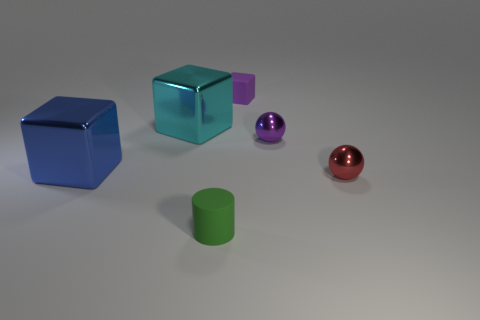What number of objects are cylinders or big purple rubber cylinders?
Give a very brief answer. 1. There is a shiny thing that is both in front of the purple shiny thing and to the right of the cyan metal cube; what is its shape?
Keep it short and to the point. Sphere. What number of tiny purple rubber cubes are there?
Ensure brevity in your answer.  1. There is a thing that is the same material as the cylinder; what color is it?
Offer a very short reply. Purple. Is the number of red metal balls greater than the number of big green cubes?
Your response must be concise. Yes. What is the size of the thing that is in front of the blue shiny cube and behind the cylinder?
Your response must be concise. Small. There is a tiny object that is the same color as the small block; what is it made of?
Provide a succinct answer. Metal. Is the number of large metallic objects on the right side of the blue metal cube the same as the number of small matte cubes?
Offer a very short reply. Yes. Is the cyan thing the same size as the matte block?
Make the answer very short. No. What is the color of the tiny thing that is in front of the small purple metallic ball and on the right side of the small block?
Your response must be concise. Red. 